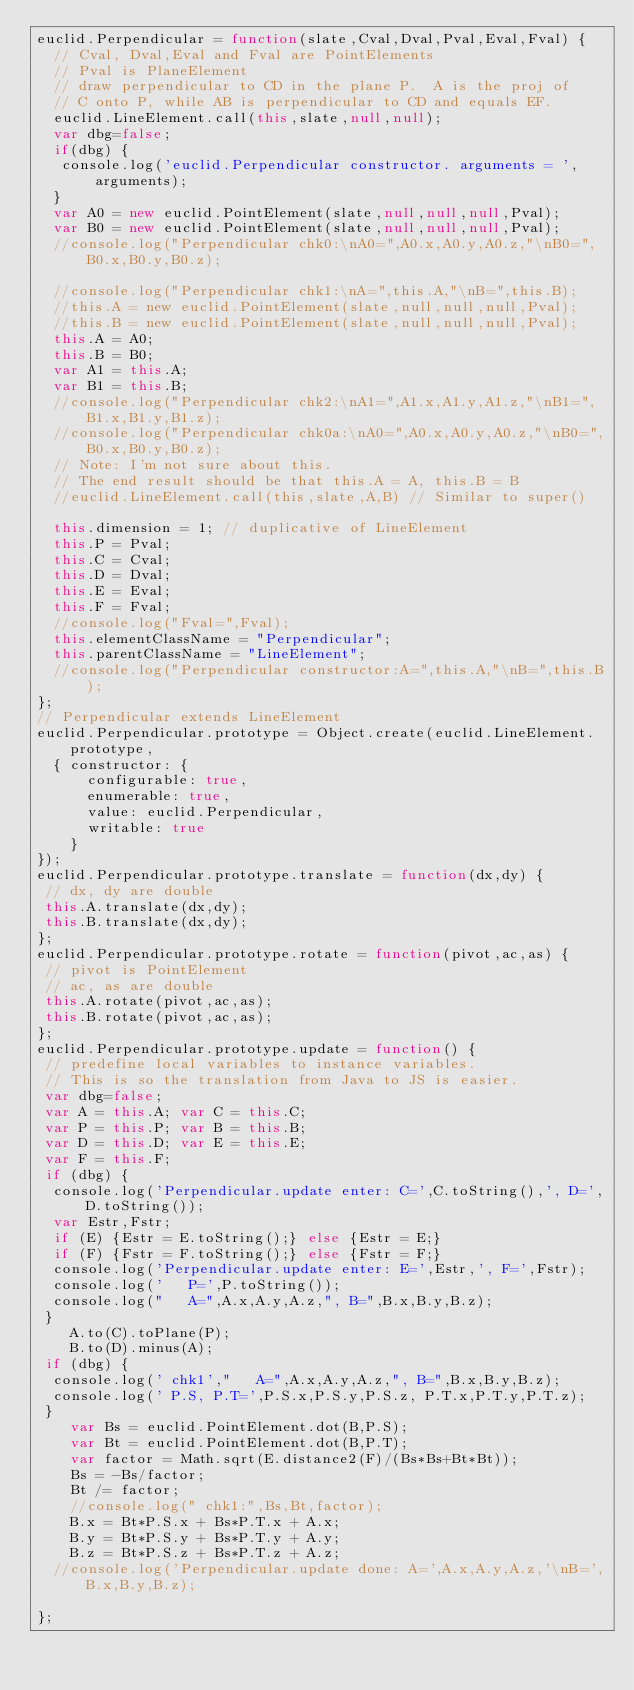<code> <loc_0><loc_0><loc_500><loc_500><_JavaScript_>euclid.Perpendicular = function(slate,Cval,Dval,Pval,Eval,Fval) {
  // Cval, Dval,Eval and Fval are PointElements
  // Pval is PlaneElement
  // draw perpendicular to CD in the plane P.  A is the proj of 
  // C onto P, while AB is perpendicular to CD and equals EF.
  euclid.LineElement.call(this,slate,null,null);
  var dbg=false;
  if(dbg) {
   console.log('euclid.Perpendicular constructor. arguments = ',arguments);
  }
  var A0 = new euclid.PointElement(slate,null,null,null,Pval);
  var B0 = new euclid.PointElement(slate,null,null,null,Pval);
  //console.log("Perpendicular chk0:\nA0=",A0.x,A0.y,A0.z,"\nB0=",B0.x,B0.y,B0.z);

  //console.log("Perpendicular chk1:\nA=",this.A,"\nB=",this.B);
  //this.A = new euclid.PointElement(slate,null,null,null,Pval);
  //this.B = new euclid.PointElement(slate,null,null,null,Pval);
  this.A = A0;
  this.B = B0;
  var A1 = this.A;
  var B1 = this.B;
  //console.log("Perpendicular chk2:\nA1=",A1.x,A1.y,A1.z,"\nB1=",B1.x,B1.y,B1.z);
  //console.log("Perpendicular chk0a:\nA0=",A0.x,A0.y,A0.z,"\nB0=",B0.x,B0.y,B0.z);
  // Note: I'm not sure about this.
  // The end result should be that this.A = A, this.B = B
  //euclid.LineElement.call(this,slate,A,B) // Similar to super()

  this.dimension = 1; // duplicative of LineElement
  this.P = Pval;
  this.C = Cval;
  this.D = Dval;
  this.E = Eval;
  this.F = Fval;
  //console.log("Fval=",Fval);
  this.elementClassName = "Perpendicular";
  this.parentClassName = "LineElement";
  //console.log("Perpendicular constructor:A=",this.A,"\nB=",this.B);
};
// Perpendicular extends LineElement
euclid.Perpendicular.prototype = Object.create(euclid.LineElement.prototype, 
  { constructor: {
      configurable: true, 
      enumerable: true,
      value: euclid.Perpendicular,
      writable: true
    }
});
euclid.Perpendicular.prototype.translate = function(dx,dy) {
 // dx, dy are double
 this.A.translate(dx,dy);
 this.B.translate(dx,dy);
};
euclid.Perpendicular.prototype.rotate = function(pivot,ac,as) {
 // pivot is PointElement
 // ac, as are double
 this.A.rotate(pivot,ac,as);
 this.B.rotate(pivot,ac,as);
};
euclid.Perpendicular.prototype.update = function() {
 // predefine local variables to instance variables.
 // This is so the translation from Java to JS is easier.
 var dbg=false;
 var A = this.A; var C = this.C;
 var P = this.P; var B = this.B;
 var D = this.D; var E = this.E;
 var F = this.F;
 if (dbg) {
  console.log('Perpendicular.update enter: C=',C.toString(),', D=',D.toString());
  var Estr,Fstr;
  if (E) {Estr = E.toString();} else {Estr = E;}
  if (F) {Fstr = F.toString();} else {Fstr = F;}
  console.log('Perpendicular.update enter: E=',Estr,', F=',Fstr);
  console.log('   P=',P.toString());
  console.log("   A=",A.x,A.y,A.z,", B=",B.x,B.y,B.z);
 }
    A.to(C).toPlane(P);
    B.to(D).minus(A);
 if (dbg) {
  console.log(' chk1',"   A=",A.x,A.y,A.z,", B=",B.x,B.y,B.z);
  console.log(' P.S, P.T=',P.S.x,P.S.y,P.S.z, P.T.x,P.T.y,P.T.z);
 }
    var Bs = euclid.PointElement.dot(B,P.S);
    var Bt = euclid.PointElement.dot(B,P.T);
    var factor = Math.sqrt(E.distance2(F)/(Bs*Bs+Bt*Bt));
    Bs = -Bs/factor;
    Bt /= factor;
    //console.log(" chk1:",Bs,Bt,factor);
    B.x = Bt*P.S.x + Bs*P.T.x + A.x;
    B.y = Bt*P.S.y + Bs*P.T.y + A.y;
    B.z = Bt*P.S.z + Bs*P.T.z + A.z; 
  //console.log('Perpendicular.update done: A=',A.x,A.y,A.z,'\nB=',B.x,B.y,B.z);

};

</code> 